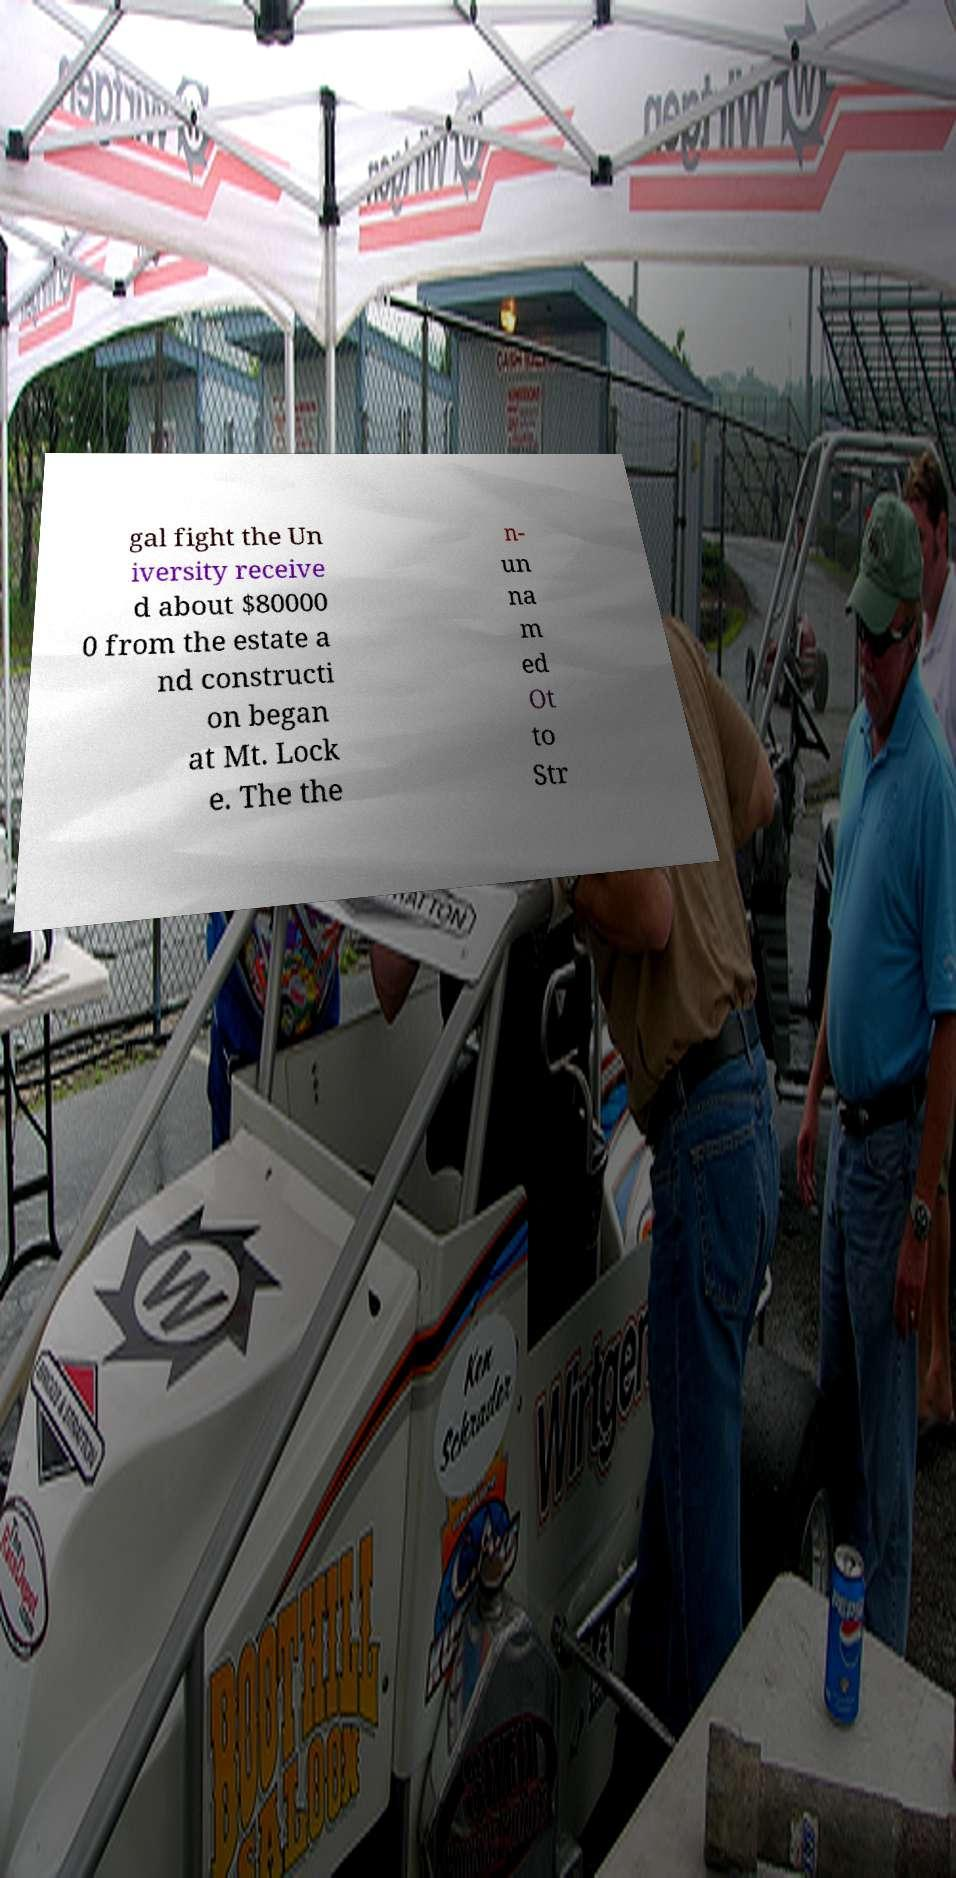Can you accurately transcribe the text from the provided image for me? gal fight the Un iversity receive d about $80000 0 from the estate a nd constructi on began at Mt. Lock e. The the n- un na m ed Ot to Str 